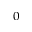Convert formula to latex. <formula><loc_0><loc_0><loc_500><loc_500>_ { 0 }</formula> 